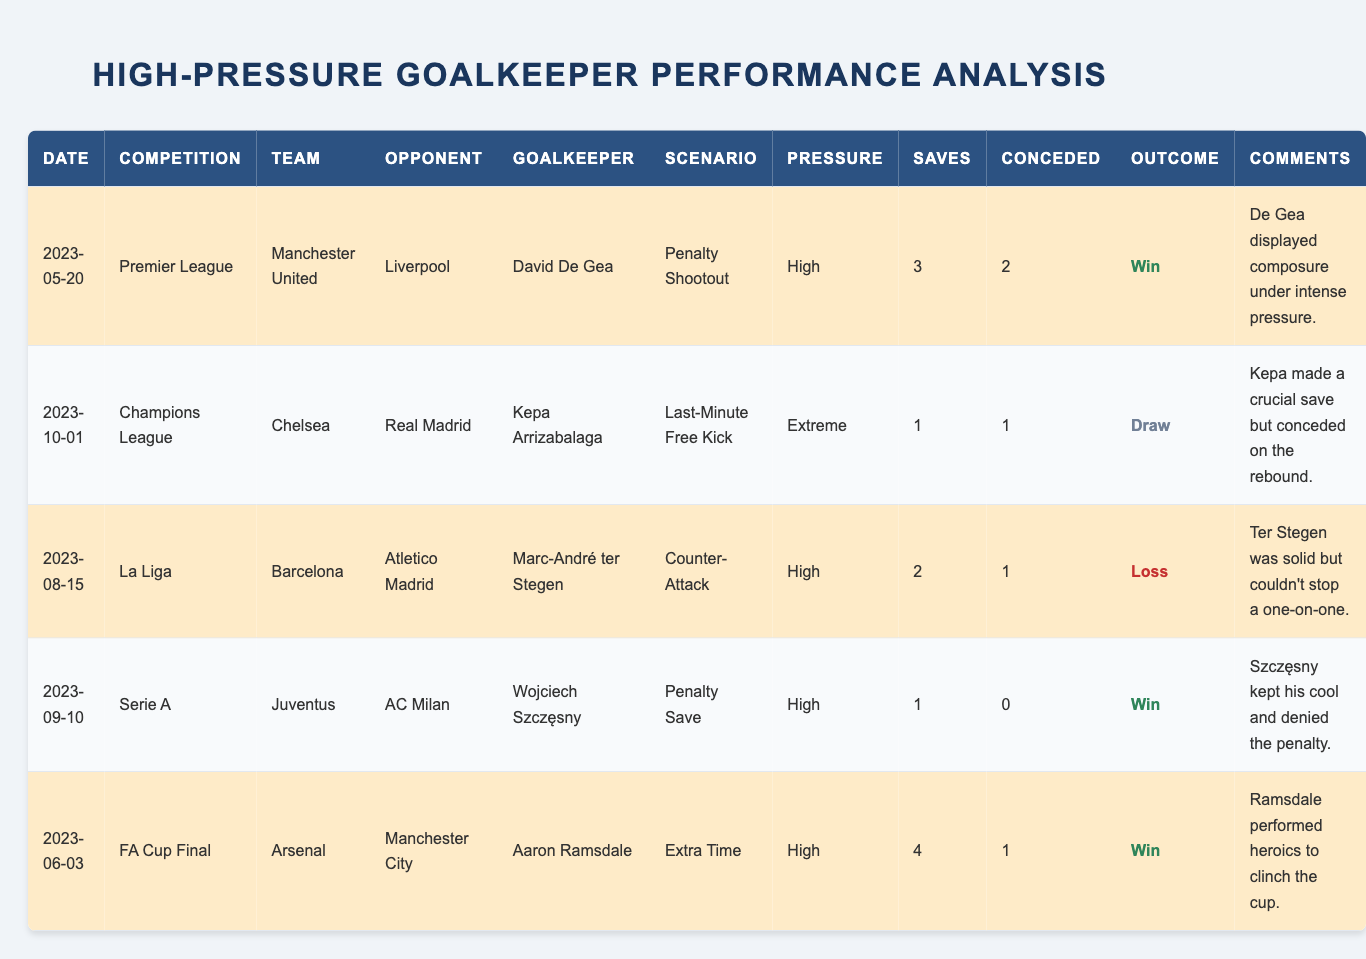What is the pressure level of the scenario involving Kepa Arrizabalaga? The data in the table clearly states that Kepa Arrizabalaga's scenario against Real Madrid had an "Extreme" pressure level.
Answer: Extreme How many successful saves did Aaron Ramsdale make in the FA Cup Final? The table shows that Aaron Ramsdale made 4 successful saves during the FA Cup Final against Manchester City.
Answer: 4 Which goalkeeper conceded the least number of goals? By looking at the table, Wojciech Szczęsny is noted for not conceding any goals in his match against AC Milan, meaning he has the least goals conceded (0).
Answer: 0 What is the average number of successful saves by goalkeepers in high-pressure scenarios? To find the average, we sum the successful saves: (3 + 1 + 2 + 1 + 4) = 11. There are 5 matches, so the average is 11/5 = 2.2.
Answer: 2.2 Was there any match that ended in a draw? When examining the outcomes in the table, it is noted that Kepa Arrizabalaga’s match against Real Madrid ended in a Draw.
Answer: Yes Which goalkeeper had a successful save count greater than 2 and did not concede goals? The table indicates that Wojciech Szczęsny had 1 successful save and 0 goals conceded, while Aaron Ramsdale had 4 successful saves and conceded 1 goal. Therefore, no goalkeeper fits this exact criteria.
Answer: None How many total goals were conceded across all matches listed in the table? To compute the total goals conceded, we add the goals conceded: (2 + 1 + 1 + 0 + 1) = 5 goals conceded in total.
Answer: 5 Which match had the highest number of successful saves by the goalkeeper and what was the match outcome? Aaron Ramsdale had the highest number of successful saves with 4 in the FA Cup Final against Manchester City, and the outcome of that match was a Win.
Answer: 4 saves, Win What percentage of matches did goalkeepers achieve a win outcome? Out of the 5 total matches, 3 ended in a win. The win percentage is then calculated as (3/5) * 100 = 60%.
Answer: 60% 